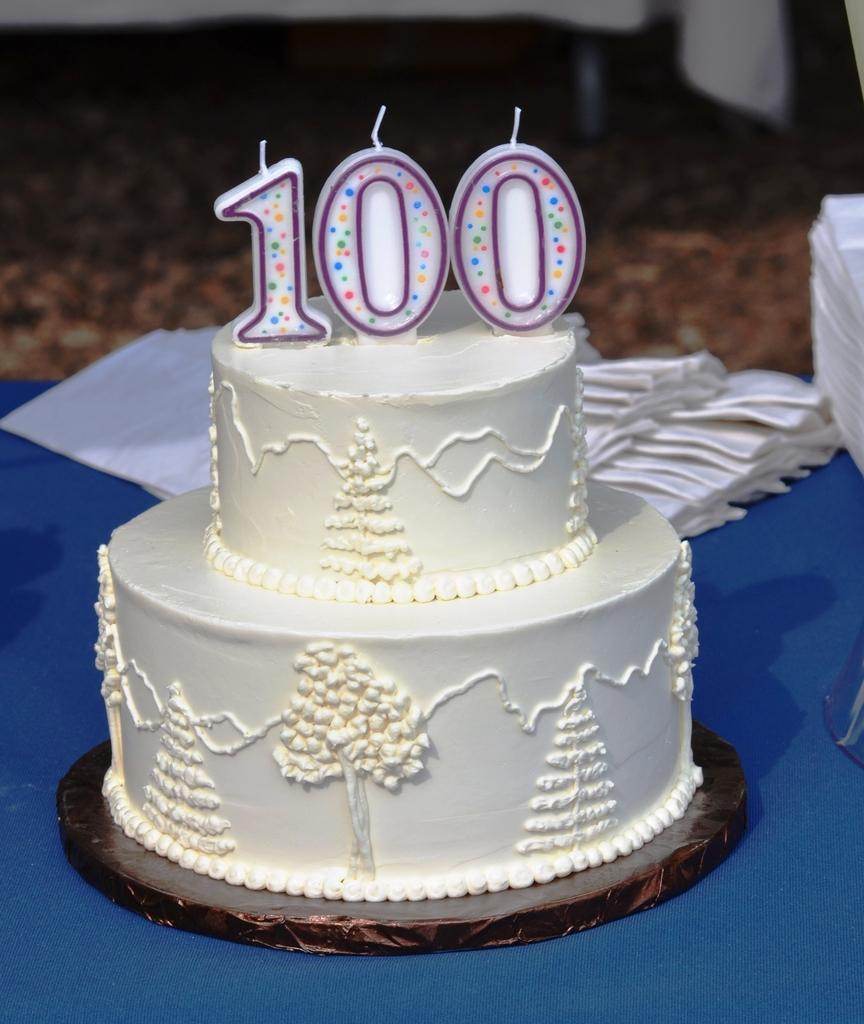What is the main subject in the center of the image? There is a cake in the center of the image. What else can be seen in the image besides the cake? There are clothes and a table visible in the image. What is the location of the table in the image? The table is at the bottom of the image. What can be seen behind the table in the image? There is a wall in the background of the image. What is visible beneath the table in the image? The floor is visible in the image. What type of lock is used to secure the underwear in the image? There is no underwear or lock present in the image. What thought is being expressed by the cake in the image? The cake is an inanimate object and cannot express thoughts. 